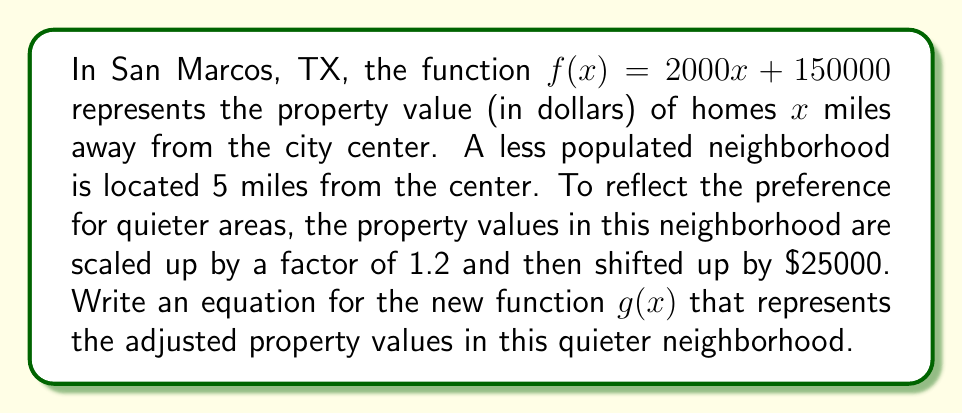Teach me how to tackle this problem. Let's approach this step-by-step:

1) The original function is $f(x) = 2000x + 150000$

2) To scale the function by a factor of 1.2, we multiply every $x$ term by 1.2:
   $1.2(2000x + 150000) = 2400x + 180000$

3) Now, we need to shift the function up by $25000. We do this by adding 25000 to the entire function:
   $2400x + 180000 + 25000 = 2400x + 205000$

4) Therefore, the new function $g(x)$ is:
   $g(x) = 2400x + 205000$

This function represents the adjusted property values in the quieter neighborhood, taking into account the scaling factor for preferring less populated areas and the upward shift in base value.
Answer: $g(x) = 2400x + 205000$ 